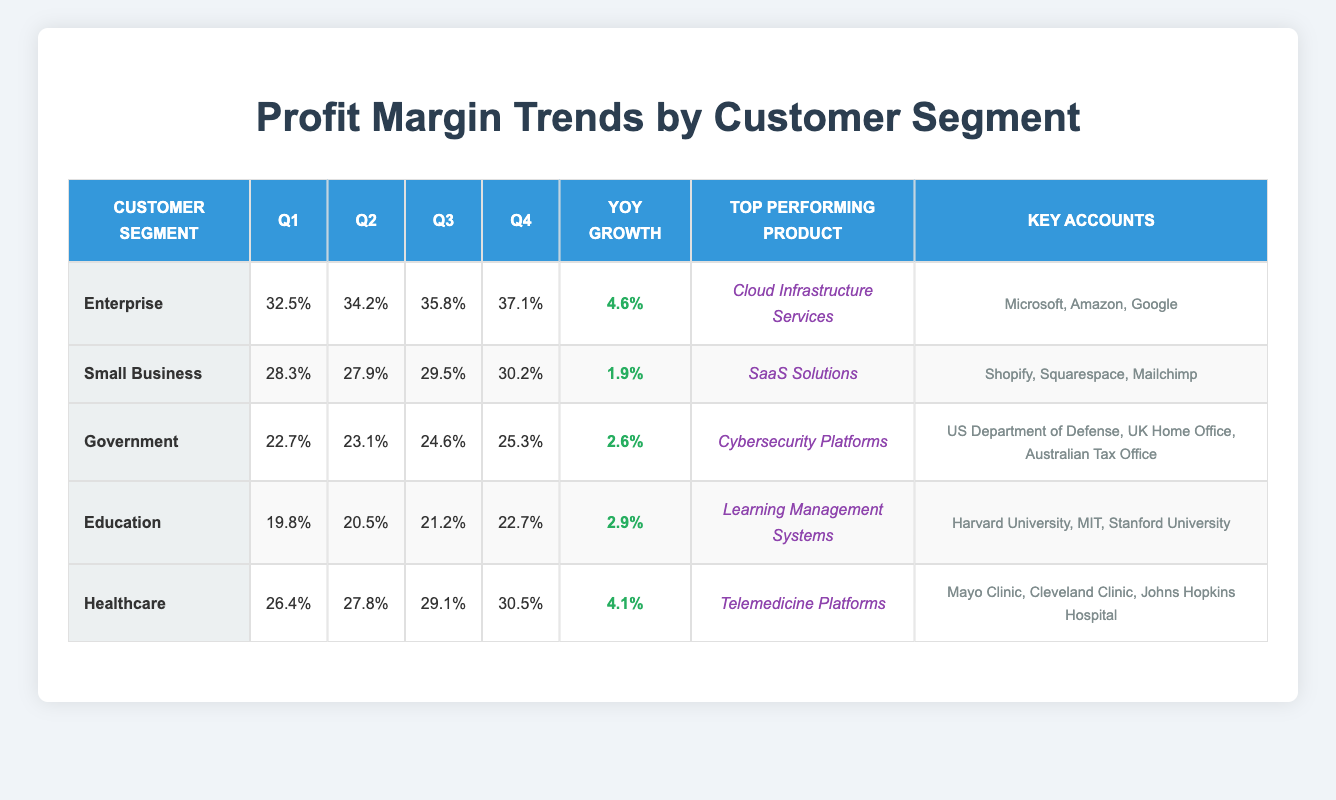What was the profit margin for the Healthcare segment in Q3? The profit margin for the Healthcare segment in Q3 is 29.1%, which can be found in the corresponding column under the Healthcare row.
Answer: 29.1% Which customer segment saw the highest profit margin in Q4? The Enterprise segment had the highest profit margin in Q4 at 37.1%, as indicated in the Q4 column for each customer segment.
Answer: Enterprise Is the profit margin for Education in Q4 higher than that for Government in Q3? In Q4, the Education profit margin is 22.7%, while in Q3, the Government profit margin is 24.6%. Since 22.7% is less than 24.6%, the statement is false.
Answer: No What was the year-over-year growth of the Small Business segment? The year-over-year growth for the Small Business segment is 1.9%, shown in the growth column corresponding to the Small Business row in the table.
Answer: 1.9% Which customer segment experienced the most significant increase in profit margin from Q1 to Q4? For Enterprise, the profit margin increased from 32.5% in Q1 to 37.1% in Q4, making a total increase of 4.6%. For Healthcare, it increased from 26.4% to 30.5%, which is a change of 4.1%. The biggest increase is for Enterprise.
Answer: Enterprise Calculate the average profit margin for the Government segment across all quarters. The profit margins for the Government segment over four quarters are 22.7%, 23.1%, 24.6%, and 25.3%. Adding them gives a total of 95.7%, and dividing by 4 results in an average of 23.925%.
Answer: 23.925% Does the Healthcare segment show more profit margin growth than the Government segment? The profit margin growth for Healthcare is 4.1%, while for Government, it is 2.6%. Since 4.1% is greater than 2.6%, the statement is true.
Answer: Yes Which top-performing product corresponds to the Small Business segment? The top-performing product for the Small Business segment is "SaaS Solutions," as highlighted in the table under the corresponding row for Small Business.
Answer: SaaS Solutions What is the median profit margin of the Education segment across all quarters? The profit margins for the Education segment are 19.8%, 20.5%, 21.2%, and 22.7%. To find the median, we arrange the numbers in ascending order and identify the middle number. The median of these four numbers (by averaging the two middle values) is (20.5 + 21.2) / 2 = 20.85%.
Answer: 20.85% 